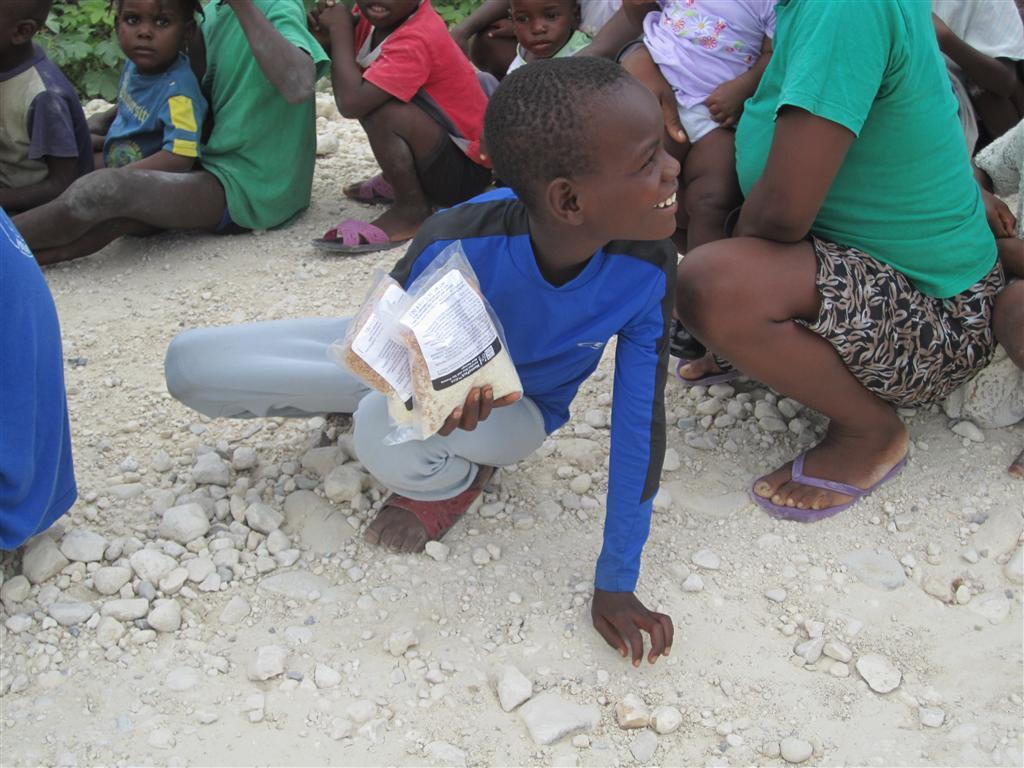How many kids are in the image? There are multiple kids in the image. Who else is present in the image besides the kids? There is a woman in the image. What can be seen at the bottom of the image? Soil and stones are visible at the bottom of the image. What is the person in the middle of the image holding? A person is holding packets in the middle of the image. What is located at the top of the image? There are plants at the top of the image. What type of carriage can be seen in the image? There is no carriage present in the image. Is there a flame visible in the image? No, there is no flame visible in the image. 